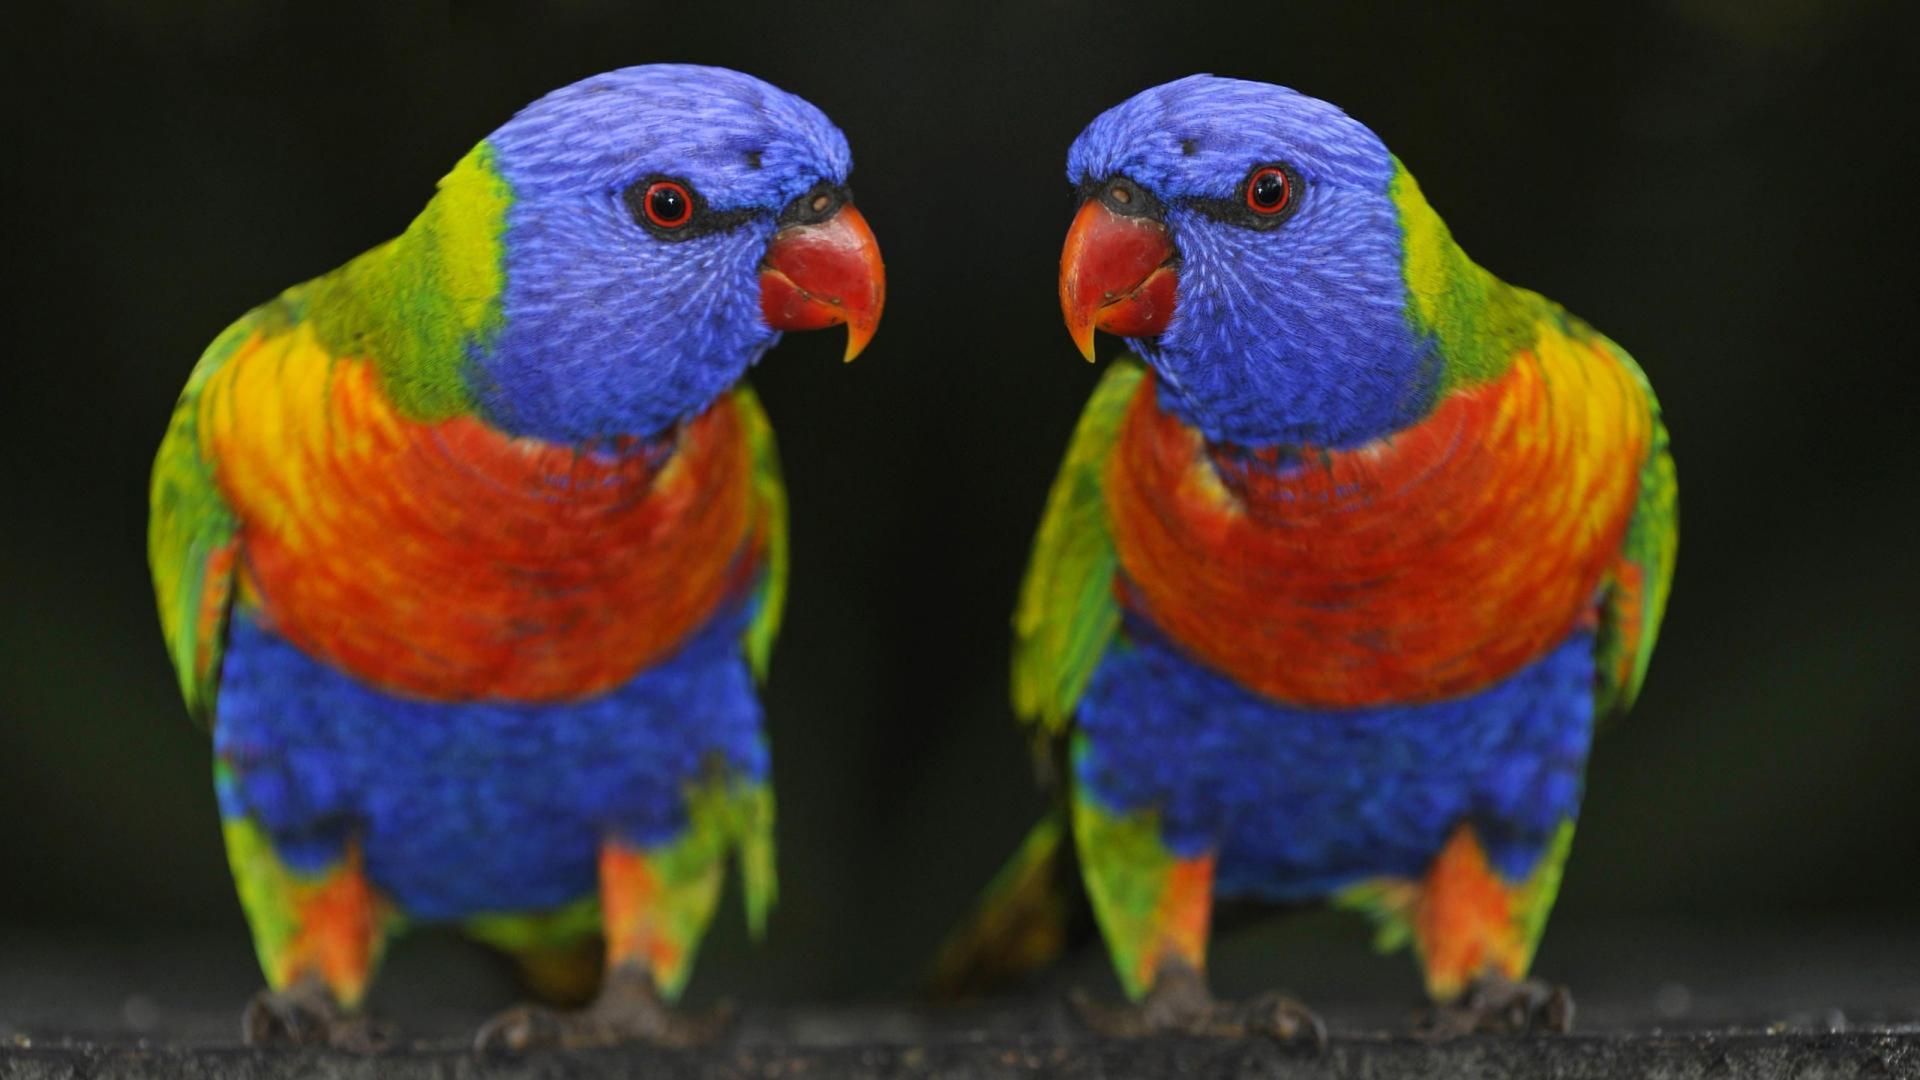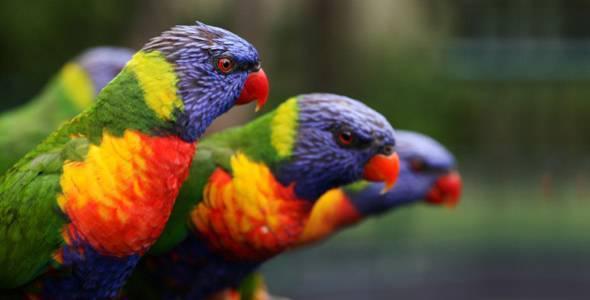The first image is the image on the left, the second image is the image on the right. Analyze the images presented: Is the assertion "There are no less than five colorful birds" valid? Answer yes or no. Yes. The first image is the image on the left, the second image is the image on the right. Evaluate the accuracy of this statement regarding the images: "There are no more than two parrots in the right image.". Is it true? Answer yes or no. No. 